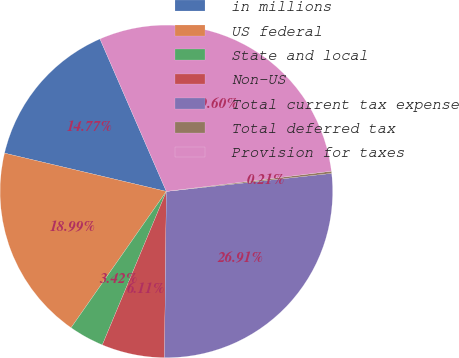<chart> <loc_0><loc_0><loc_500><loc_500><pie_chart><fcel>in millions<fcel>US federal<fcel>State and local<fcel>Non-US<fcel>Total current tax expense<fcel>Total deferred tax<fcel>Provision for taxes<nl><fcel>14.77%<fcel>18.99%<fcel>3.42%<fcel>6.11%<fcel>26.91%<fcel>0.21%<fcel>29.6%<nl></chart> 